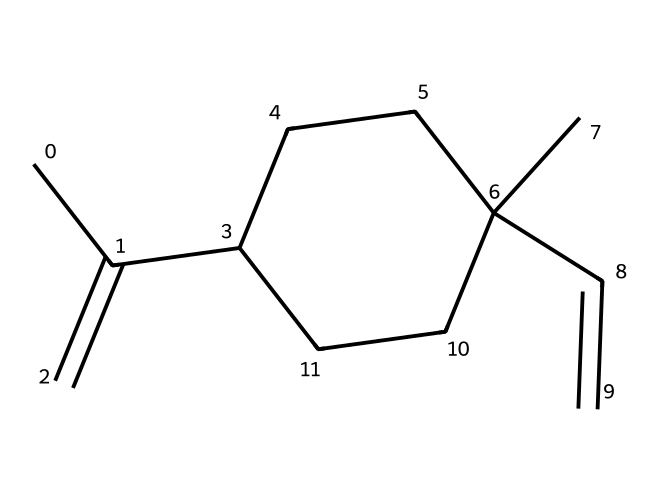What is the total number of carbon atoms in this molecule? By analyzing the SMILES representation, we can identify each 'C' which indicates a carbon atom. The representation includes 15 carbon atoms in total.
Answer: 15 How many double bonds are present in the structure? The structure contains two instances of "=" which indicates double bonds between atoms. Counting these, there are 2 double bonds in total.
Answer: 2 What type of compound is represented by this SMILES notation? The chemical structure suggests it is a hydrocarbon due to the presence of only carbon and hydrogen atoms, and given the structure, it is categorized as an alkene.
Answer: alkene What functional group is suggested by the double bonds in this compound? The presence of double bonds signifies that the compound can contain alkenes, which is a specific functional group characterized by carbon-carbon double bonds.
Answer: alkenes How many hydrogen atoms are in the molecule? Each carbon typically bonds with hydrogens, and based on the carbon count and the presence of double bonds, the total number of hydrogen atoms can be calculated. There are 24 hydrogen atoms overall in this molecule.
Answer: 24 What is the significance of the branched structure in terms of volatility? The branched structure generally leads to lower boiling points compared to straight-chain isomers, indicating that this compound is likely more volatile and can evaporate more easily.
Answer: lower volatility Does this compound have any cyclic structures based on the SMILES? The 'C1' notation indicates the start of a cyclic structure. By confirming this within the SMILES and counting the segments, we verify that there is one cyclic structure present in the compound.
Answer: 1 